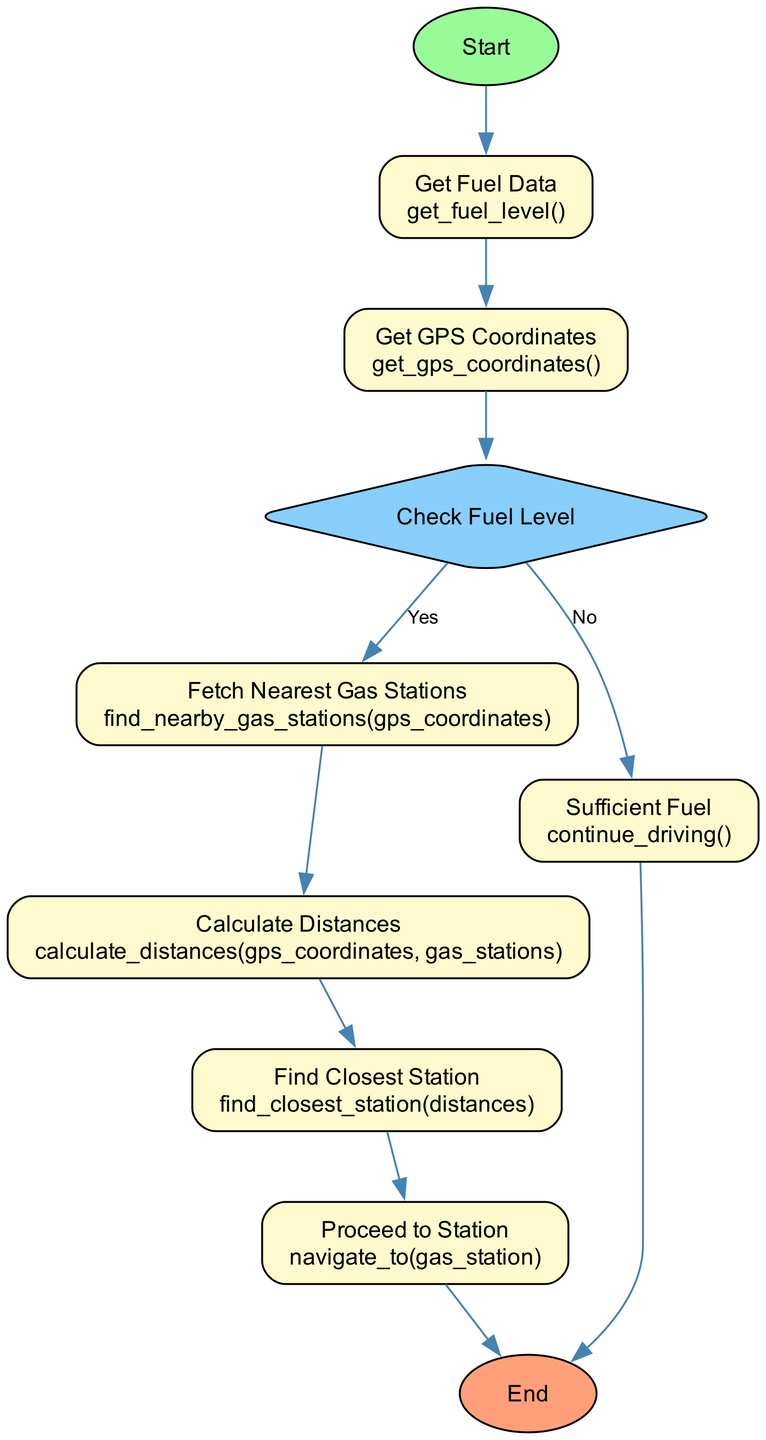What is the first step in the process? The first step is labeled as "Start," which initializes the process of calculating remaining fuel and finding the nearest gas station.
Answer: Start How many processes are there in the diagram? There are six processes: "Get Fuel Data," "Get GPS Coordinates," "Fetch Nearest Gas Stations," "Calculate Distances," "Find Closest Station," and "Proceed to Station."
Answer: Six What function does the "Check Fuel Level" decision node point to if the answer is yes? If the answer is yes, the "Check Fuel Level" decision node points to the "Fetch Nearest Gas Stations" process, indicating that the system will look for nearby gas stations.
Answer: Fetch Nearest Gas Stations What happens if the fuel level is above the critical threshold? If the fuel level is above the critical threshold, the process continues to the "Sufficient Fuel" node, where the cab will proceed with driving as usual without finding gas stations.
Answer: Continue driving Which node follows the "Calculate Distances" process? The node that follows "Calculate Distances" is "Find Closest Station," which means that after calculating distances, the next step is to identify the nearest gas station.
Answer: Find Closest Station What decision does the diagram make after checking the fuel level? After checking the fuel level, the diagram makes a decision to either fetch the nearest gas stations (if fuel is below the critical threshold) or conclude that there is sufficient fuel.
Answer: Fetch nearest gas stations or Sufficient fuel What is the last node in the flowchart? The last node in the flowchart is labeled "End," signifying the completion of the entire process of calculating remaining fuel and finding the nearest gas station.
Answer: End How many edges connect to the "Get GPS Coordinates" node? There is one edge connecting to the "Get GPS Coordinates" node, which comes from the "Get Fuel Data" node, indicating the sequence of steps.
Answer: One 